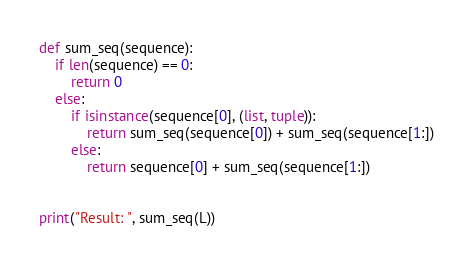Convert code to text. <code><loc_0><loc_0><loc_500><loc_500><_Python_>
def sum_seq(sequence):
    if len(sequence) == 0:
        return 0
    else:
        if isinstance(sequence[0], (list, tuple)):
            return sum_seq(sequence[0]) + sum_seq(sequence[1:])
        else:
            return sequence[0] + sum_seq(sequence[1:])


print("Result: ", sum_seq(L))
</code> 